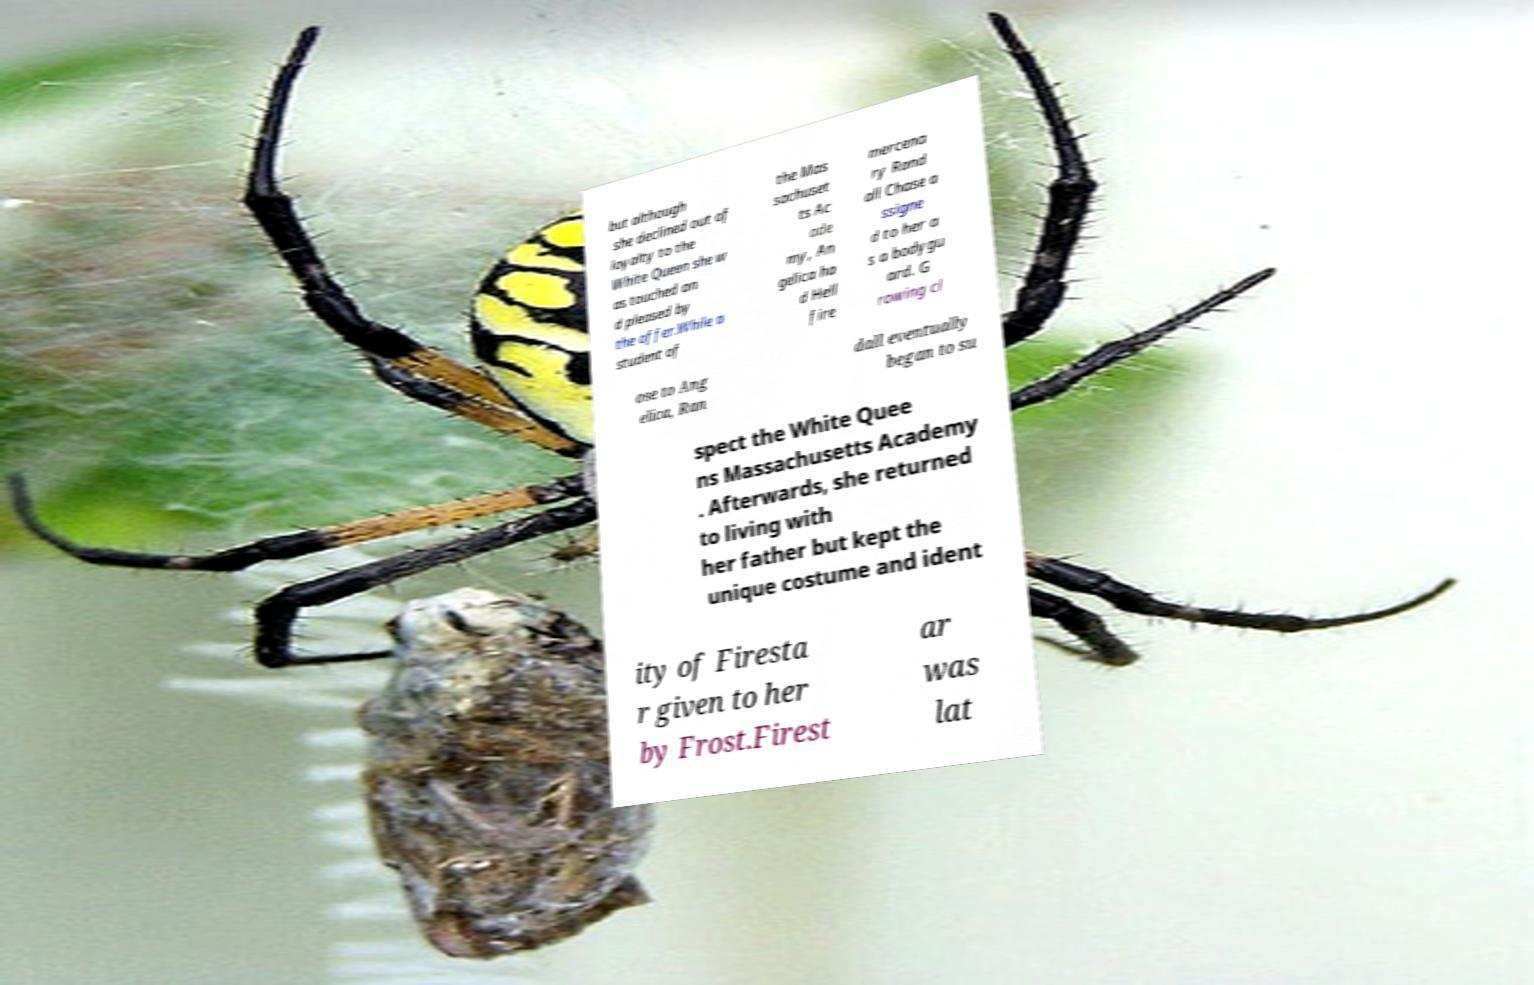Could you assist in decoding the text presented in this image and type it out clearly? but although she declined out of loyalty to the White Queen she w as touched an d pleased by the offer.While a student of the Mas sachuset ts Ac ade my, An gelica ha d Hell fire mercena ry Rand all Chase a ssigne d to her a s a bodygu ard. G rowing cl ose to Ang elica, Ran dall eventually began to su spect the White Quee ns Massachusetts Academy . Afterwards, she returned to living with her father but kept the unique costume and ident ity of Firesta r given to her by Frost.Firest ar was lat 